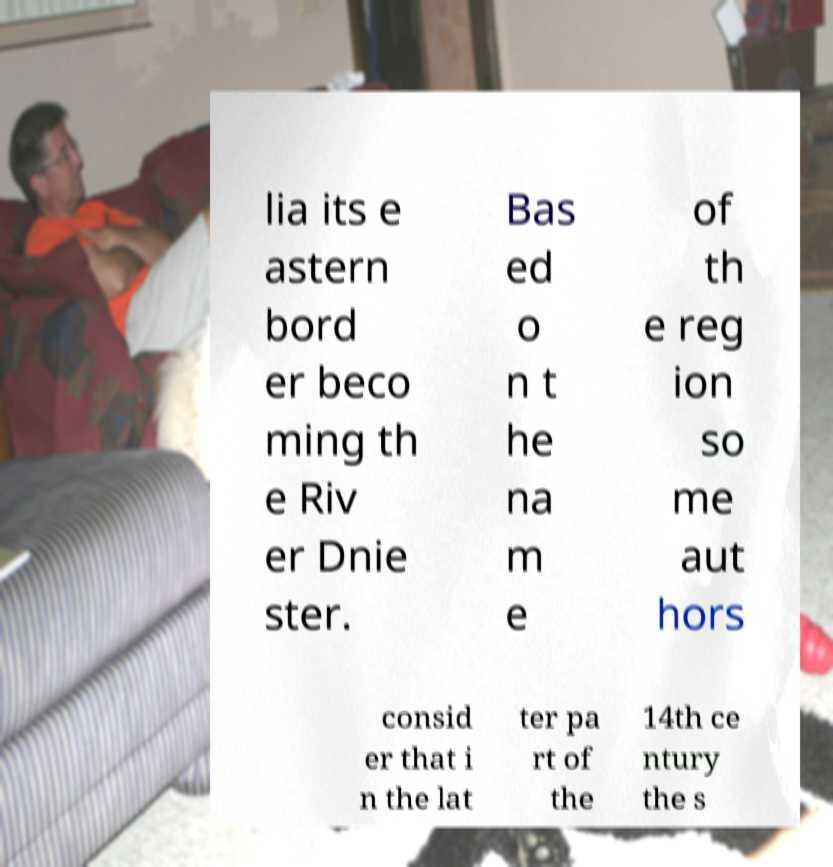Could you assist in decoding the text presented in this image and type it out clearly? lia its e astern bord er beco ming th e Riv er Dnie ster. Bas ed o n t he na m e of th e reg ion so me aut hors consid er that i n the lat ter pa rt of the 14th ce ntury the s 